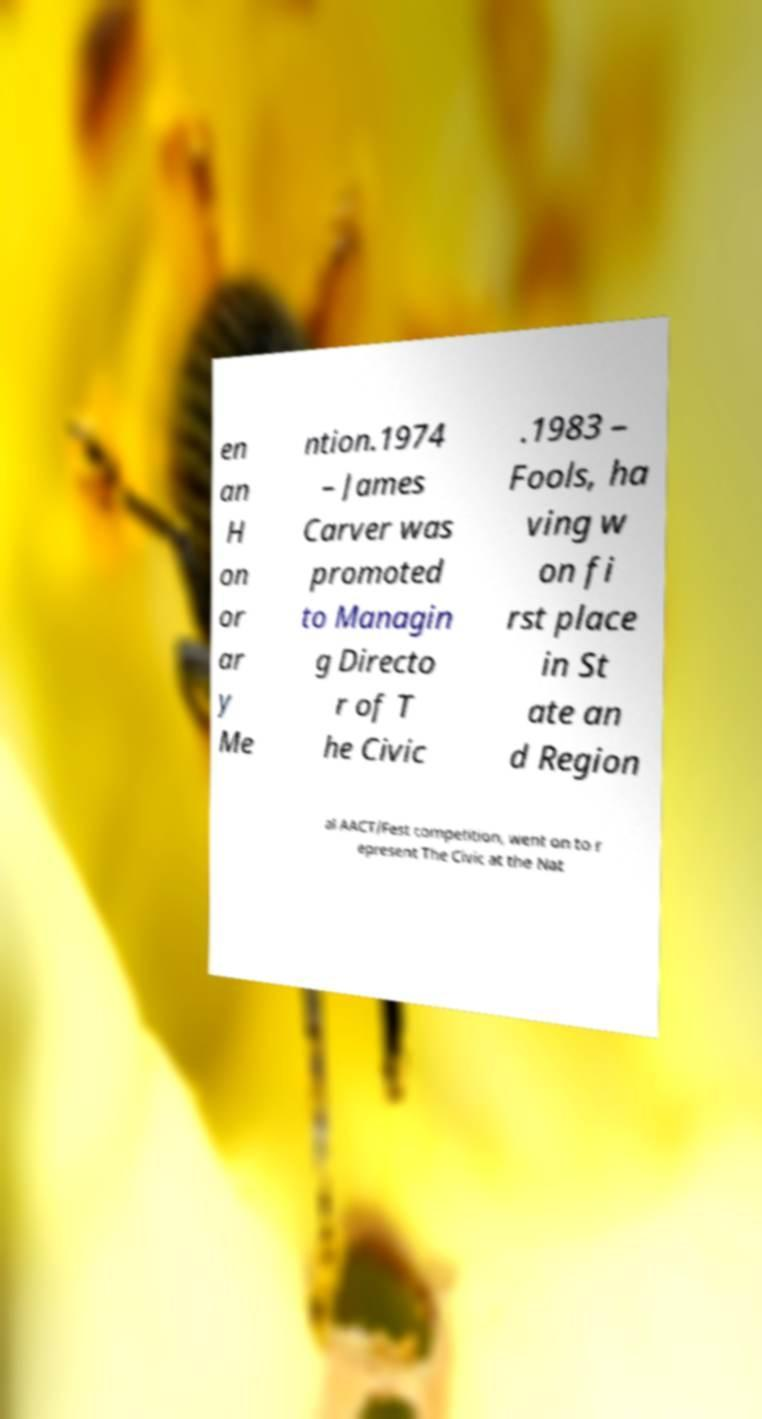Can you accurately transcribe the text from the provided image for me? en an H on or ar y Me ntion.1974 – James Carver was promoted to Managin g Directo r of T he Civic .1983 – Fools, ha ving w on fi rst place in St ate an d Region al AACT/Fest competition, went on to r epresent The Civic at the Nat 